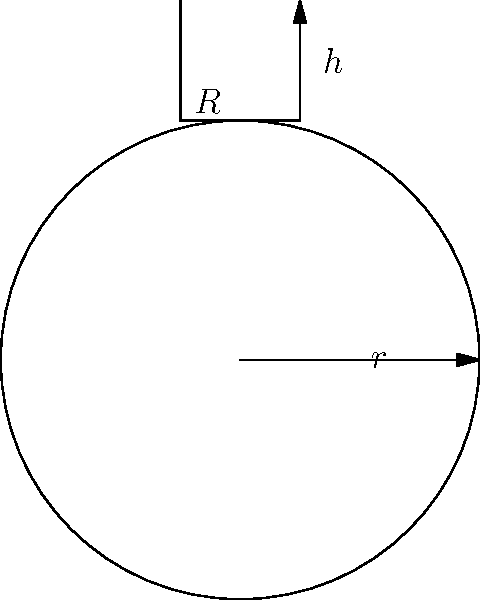In the magical realm of Algebraic Potions, a master alchemist crafts a unique bottle for her latest concoction. The bottle resembles a sphere with a radius of 6 inches, topped by a cylindrical neck with a height of 3 inches and a radius of 2 inches. If the alchemist fills this mystical vessel to the brim, how many cubic inches of potion will it hold? (Use $\pi = 3.14$ for your calculations and round your answer to the nearest whole number.) Let's approach this enchanting problem step by step:

1) First, we need to calculate the volume of the spherical part:
   The volume of a sphere is given by $V_{sphere} = \frac{4}{3}\pi r^3$
   $V_{sphere} = \frac{4}{3} \times 3.14 \times 6^3 = 904.32$ cubic inches

2) Next, let's calculate the volume of the cylindrical neck:
   The volume of a cylinder is given by $V_{cylinder} = \pi r^2 h$
   $V_{cylinder} = 3.14 \times 2^2 \times 3 = 37.68$ cubic inches

3) However, we need to subtract the volume of the spherical cap that the neck replaces:
   The volume of a spherical cap is given by $V_{cap} = \frac{1}{3}\pi h^2 (3r - h)$
   where $h$ is the height of the cap (which is the same as the radius of the neck)
   $V_{cap} = \frac{1}{3} \times 3.14 \times 2^2 (3 \times 6 - 2) = 75.36$ cubic inches

4) Now, we can combine these magical volumes:
   $V_{total} = V_{sphere} - V_{cap} + V_{cylinder}$
   $V_{total} = 904.32 - 75.36 + 37.68 = 866.64$ cubic inches

5) Rounding to the nearest whole number:
   $V_{total} \approx 867$ cubic inches

Thus, our mystical potion bottle can hold approximately 867 cubic inches of the alchemist's magical brew.
Answer: 867 cubic inches 